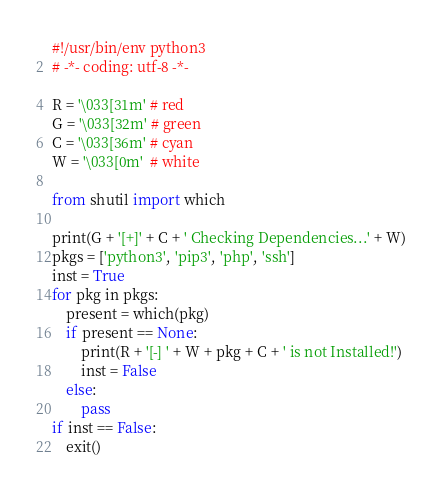<code> <loc_0><loc_0><loc_500><loc_500><_Python_>#!/usr/bin/env python3
# -*- coding: utf-8 -*-

R = '\033[31m' # red
G = '\033[32m' # green
C = '\033[36m' # cyan
W = '\033[0m'  # white

from shutil import which

print(G + '[+]' + C + ' Checking Dependencies...' + W)
pkgs = ['python3', 'pip3', 'php', 'ssh']
inst = True
for pkg in pkgs:
	present = which(pkg)
	if present == None:
		print(R + '[-] ' + W + pkg + C + ' is not Installed!')
		inst = False
	else:
		pass
if inst == False:
	exit()</code> 